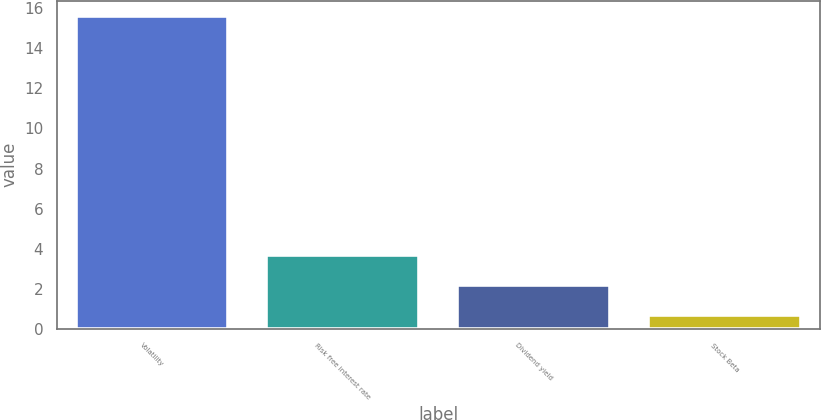Convert chart. <chart><loc_0><loc_0><loc_500><loc_500><bar_chart><fcel>Volatility<fcel>Risk free interest rate<fcel>Dividend yield<fcel>Stock Beta<nl><fcel>15.6<fcel>3.67<fcel>2.18<fcel>0.69<nl></chart> 